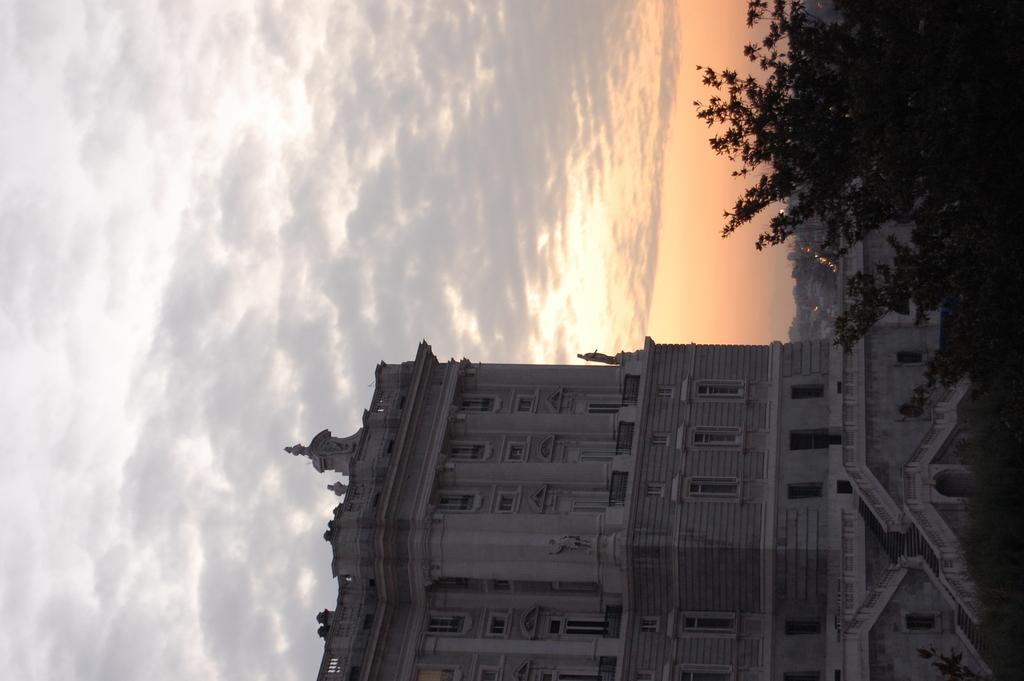Describe this image in one or two sentences. In this image there is a building. Right top there are trees. Behind there are buildings. Top of the image there is sky with clouds. 